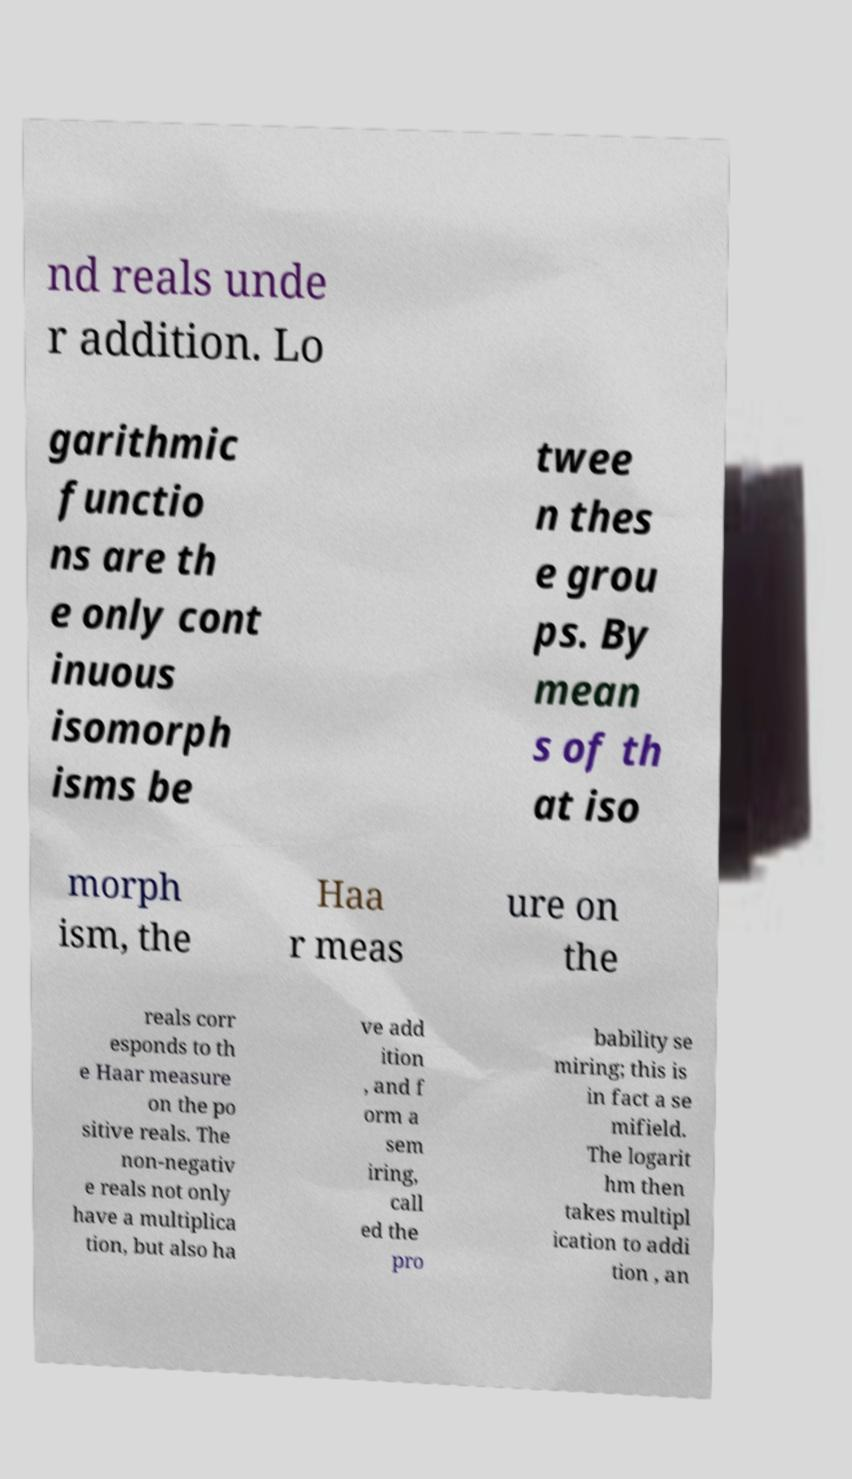Could you extract and type out the text from this image? nd reals unde r addition. Lo garithmic functio ns are th e only cont inuous isomorph isms be twee n thes e grou ps. By mean s of th at iso morph ism, the Haa r meas ure on the reals corr esponds to th e Haar measure on the po sitive reals. The non-negativ e reals not only have a multiplica tion, but also ha ve add ition , and f orm a sem iring, call ed the pro bability se miring; this is in fact a se mifield. The logarit hm then takes multipl ication to addi tion , an 